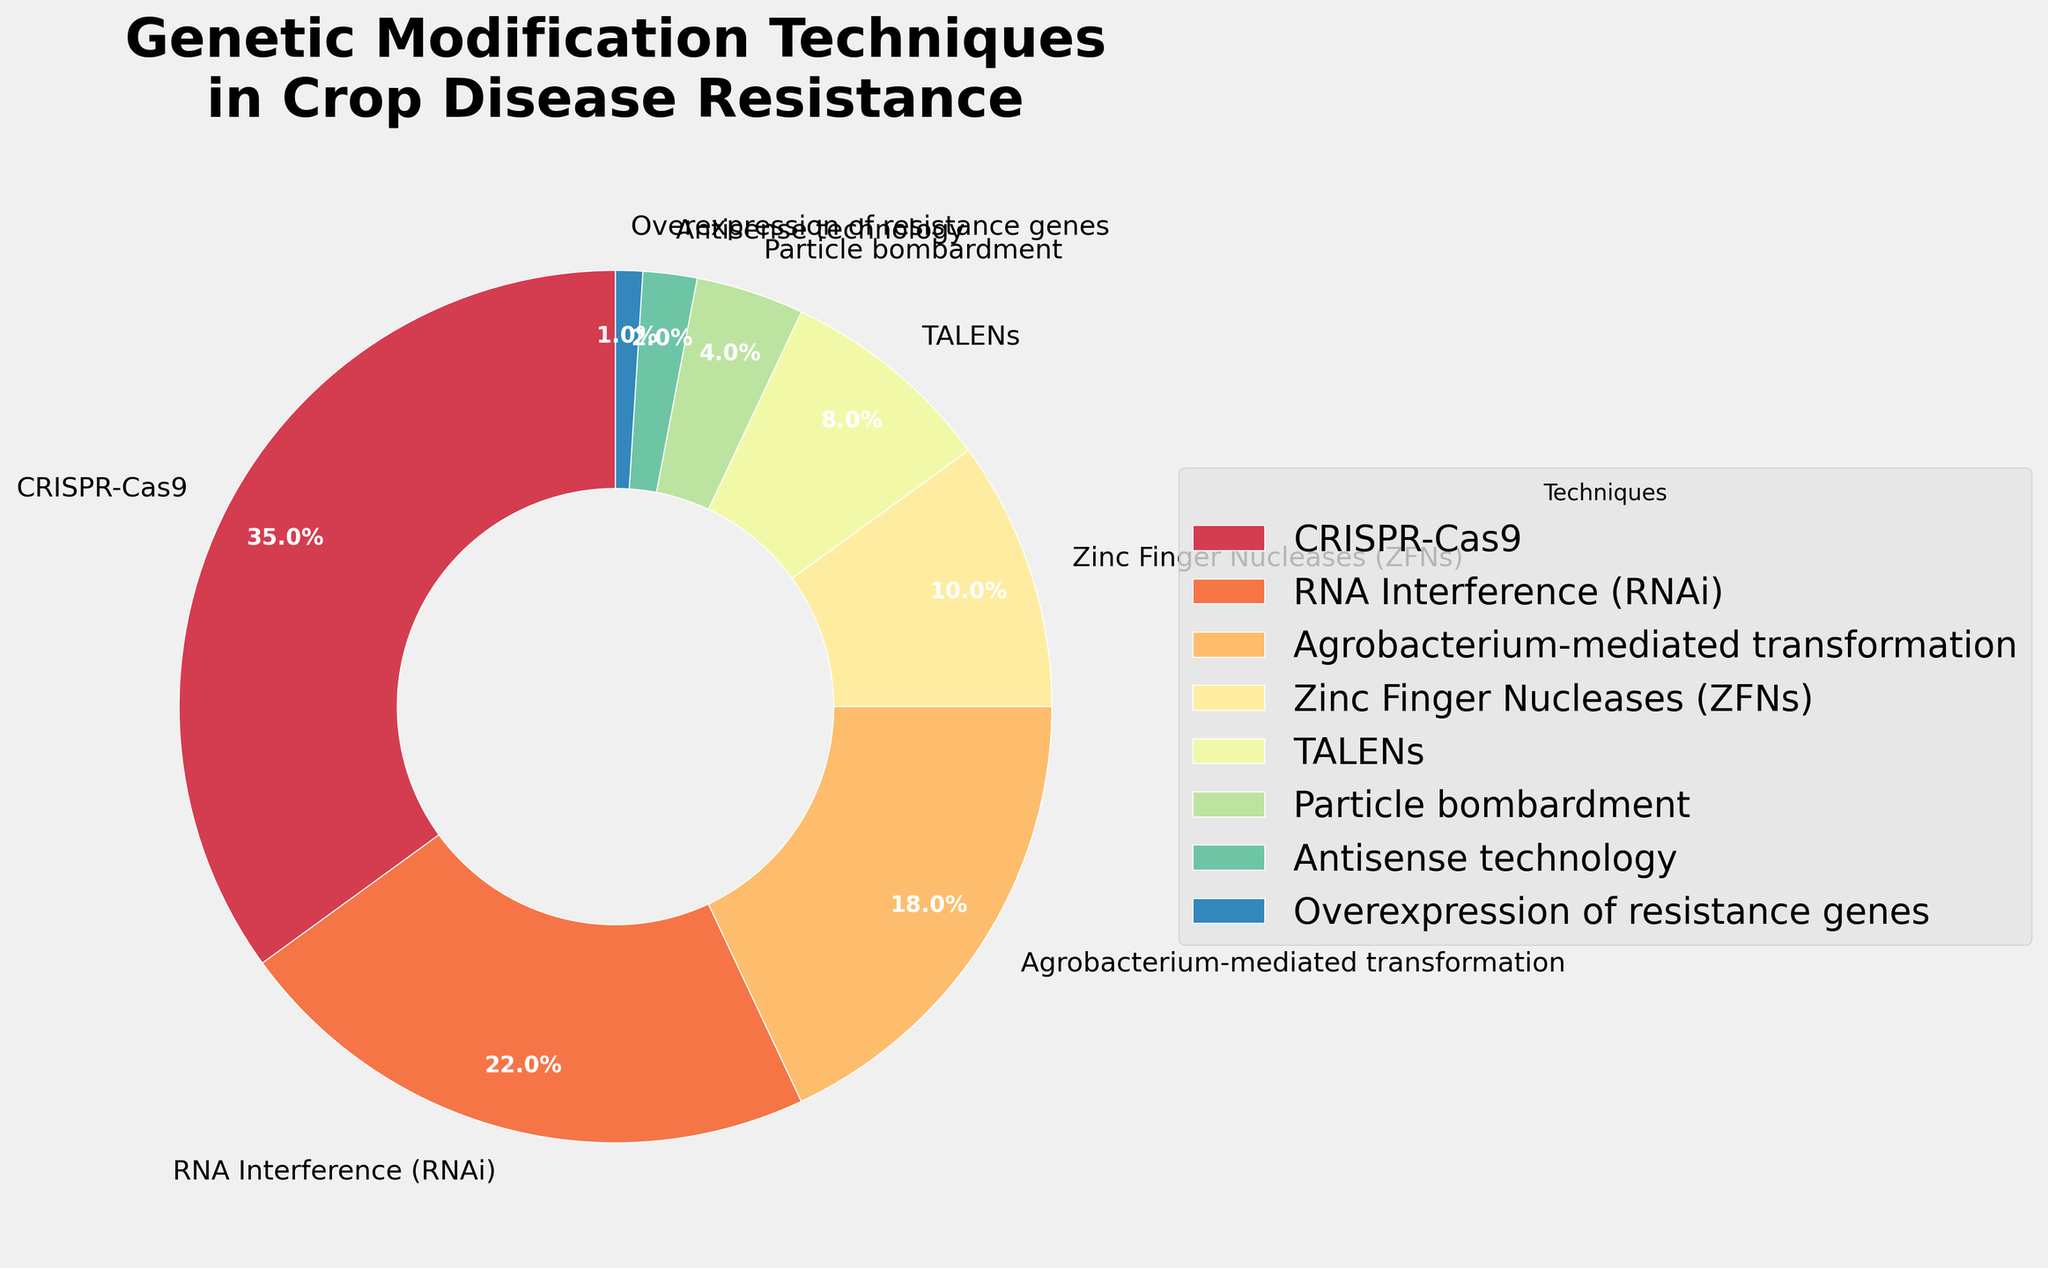What percentage of the techniques are used more than Particle bombardment? First, identify the techniques used more than Particle bombardment (4%): CRISPR-Cas9 (35%), RNA Interference (RNAi) (22%), Agrobacterium-mediated transformation (18%), Zinc Finger Nucleases (ZFNs) (10%), TALENs (8%). Sum these percentages: 35 + 22 + 18 + 10 + 8 = 93%.
Answer: 93% Which technique occupies the smallest portion of the pie chart? Look for the technique with the smallest percentage. It is Overexpression of resistance genes with 1%.
Answer: Overexpression of resistance genes How much larger is the percentage of CRISPR-Cas9 compared to Antisense technology? Subtract the percentage of Antisense technology (2%) from the percentage of CRISPR-Cas9 (35%): 35 - 2 = 33%.
Answer: 33% What is the combined percentage of RNA Interference and TALENs? Add the percentage of RNA Interference (22%) to the percentage of TALENs (8%): 22 + 8 = 30%.
Answer: 30% Is RNA Interference used more or less than Agrobacterium-mediated transformation? Compare the percentages of RNA Interference (22%) and Agrobacterium-mediated transformation (18%). RNA Interference is used more.
Answer: More List the techniques in descending order based on their percentage. Arrange the techniques by their percentage from highest to lowest: CRISPR-Cas9 (35%), RNA Interference (22%), Agrobacterium-mediated transformation (18%), Zinc Finger Nucleases (10%), TALENs (8%), Particle bombardment (4%), Antisense technology (2%), Overexpression of resistance genes (1%).
Answer: CRISPR-Cas9, RNA Interference (RNAi), Agrobacterium-mediated transformation, Zinc Finger Nucleases (ZFNs), TALENs, Particle bombardment, Antisense technology, Overexpression of resistance genes What percentage of the techniques account for less than 10% each? Identify techniques with less than 10%: Zinc Finger Nucleases (10%), TALENs (8%), Particle bombardment (4%), Antisense technology (2%), Overexpression of resistance genes (1%). Sum these percentages: 10 + 8 + 4 + 2 + 1 = 25%.
Answer: 25% What is the difference in percentage between Agrobacterium-mediated transformation and Zinc Finger Nucleases? Subtract the percentage of Zinc Finger Nucleases (10%) from Agrobacterium-mediated transformation (18%): 18 - 10 = 8%.
Answer: 8% Does Particle bombardment occupy more or less than half of the percentage of Agrobacterium-mediated transformation? Check half of Agrobacterium-mediated transformation (18% / 2 = 9%). Particle bombardment (4%) is less than 9%.
Answer: Less What is the total percentage of all techniques listed? Sum the percentages of all the techniques: 35 + 22 + 18 + 10 + 8 + 4 + 2 + 1 = 100%.
Answer: 100% 